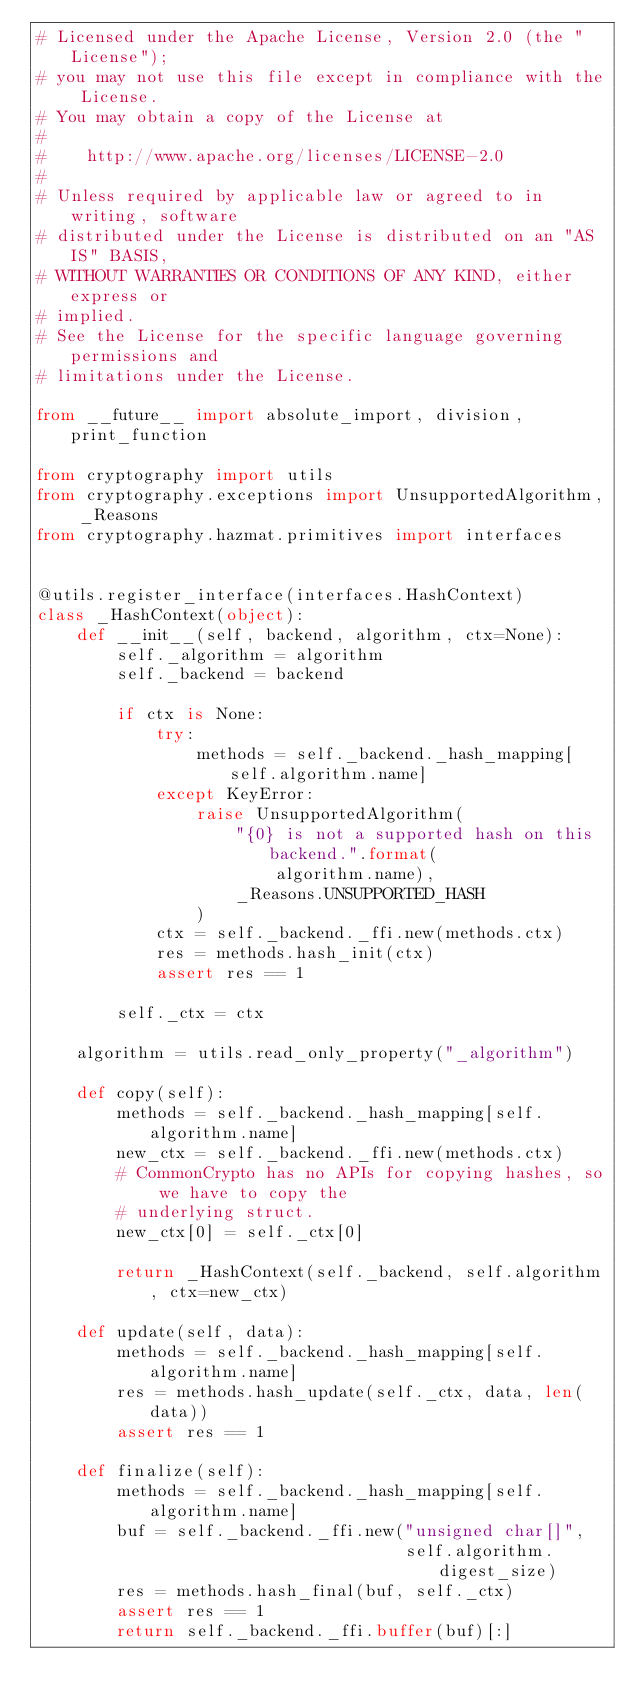<code> <loc_0><loc_0><loc_500><loc_500><_Python_># Licensed under the Apache License, Version 2.0 (the "License");
# you may not use this file except in compliance with the License.
# You may obtain a copy of the License at
#
#    http://www.apache.org/licenses/LICENSE-2.0
#
# Unless required by applicable law or agreed to in writing, software
# distributed under the License is distributed on an "AS IS" BASIS,
# WITHOUT WARRANTIES OR CONDITIONS OF ANY KIND, either express or
# implied.
# See the License for the specific language governing permissions and
# limitations under the License.

from __future__ import absolute_import, division, print_function

from cryptography import utils
from cryptography.exceptions import UnsupportedAlgorithm, _Reasons
from cryptography.hazmat.primitives import interfaces


@utils.register_interface(interfaces.HashContext)
class _HashContext(object):
    def __init__(self, backend, algorithm, ctx=None):
        self._algorithm = algorithm
        self._backend = backend

        if ctx is None:
            try:
                methods = self._backend._hash_mapping[self.algorithm.name]
            except KeyError:
                raise UnsupportedAlgorithm(
                    "{0} is not a supported hash on this backend.".format(
                        algorithm.name),
                    _Reasons.UNSUPPORTED_HASH
                )
            ctx = self._backend._ffi.new(methods.ctx)
            res = methods.hash_init(ctx)
            assert res == 1

        self._ctx = ctx

    algorithm = utils.read_only_property("_algorithm")

    def copy(self):
        methods = self._backend._hash_mapping[self.algorithm.name]
        new_ctx = self._backend._ffi.new(methods.ctx)
        # CommonCrypto has no APIs for copying hashes, so we have to copy the
        # underlying struct.
        new_ctx[0] = self._ctx[0]

        return _HashContext(self._backend, self.algorithm, ctx=new_ctx)

    def update(self, data):
        methods = self._backend._hash_mapping[self.algorithm.name]
        res = methods.hash_update(self._ctx, data, len(data))
        assert res == 1

    def finalize(self):
        methods = self._backend._hash_mapping[self.algorithm.name]
        buf = self._backend._ffi.new("unsigned char[]",
                                     self.algorithm.digest_size)
        res = methods.hash_final(buf, self._ctx)
        assert res == 1
        return self._backend._ffi.buffer(buf)[:]
</code> 